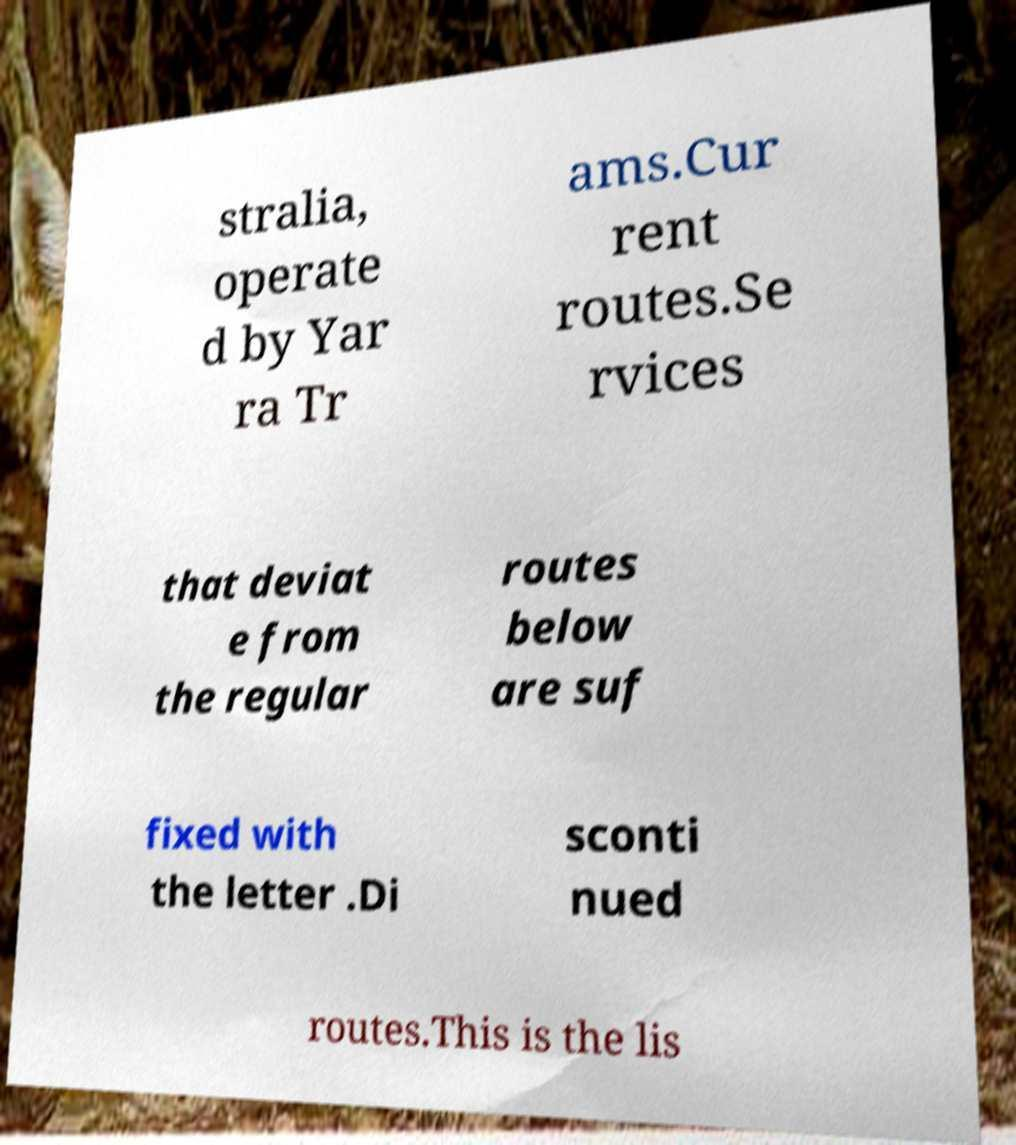Could you assist in decoding the text presented in this image and type it out clearly? stralia, operate d by Yar ra Tr ams.Cur rent routes.Se rvices that deviat e from the regular routes below are suf fixed with the letter .Di sconti nued routes.This is the lis 